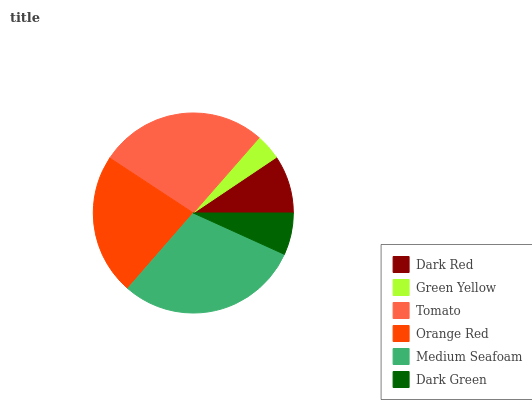Is Green Yellow the minimum?
Answer yes or no. Yes. Is Medium Seafoam the maximum?
Answer yes or no. Yes. Is Tomato the minimum?
Answer yes or no. No. Is Tomato the maximum?
Answer yes or no. No. Is Tomato greater than Green Yellow?
Answer yes or no. Yes. Is Green Yellow less than Tomato?
Answer yes or no. Yes. Is Green Yellow greater than Tomato?
Answer yes or no. No. Is Tomato less than Green Yellow?
Answer yes or no. No. Is Orange Red the high median?
Answer yes or no. Yes. Is Dark Red the low median?
Answer yes or no. Yes. Is Dark Red the high median?
Answer yes or no. No. Is Dark Green the low median?
Answer yes or no. No. 